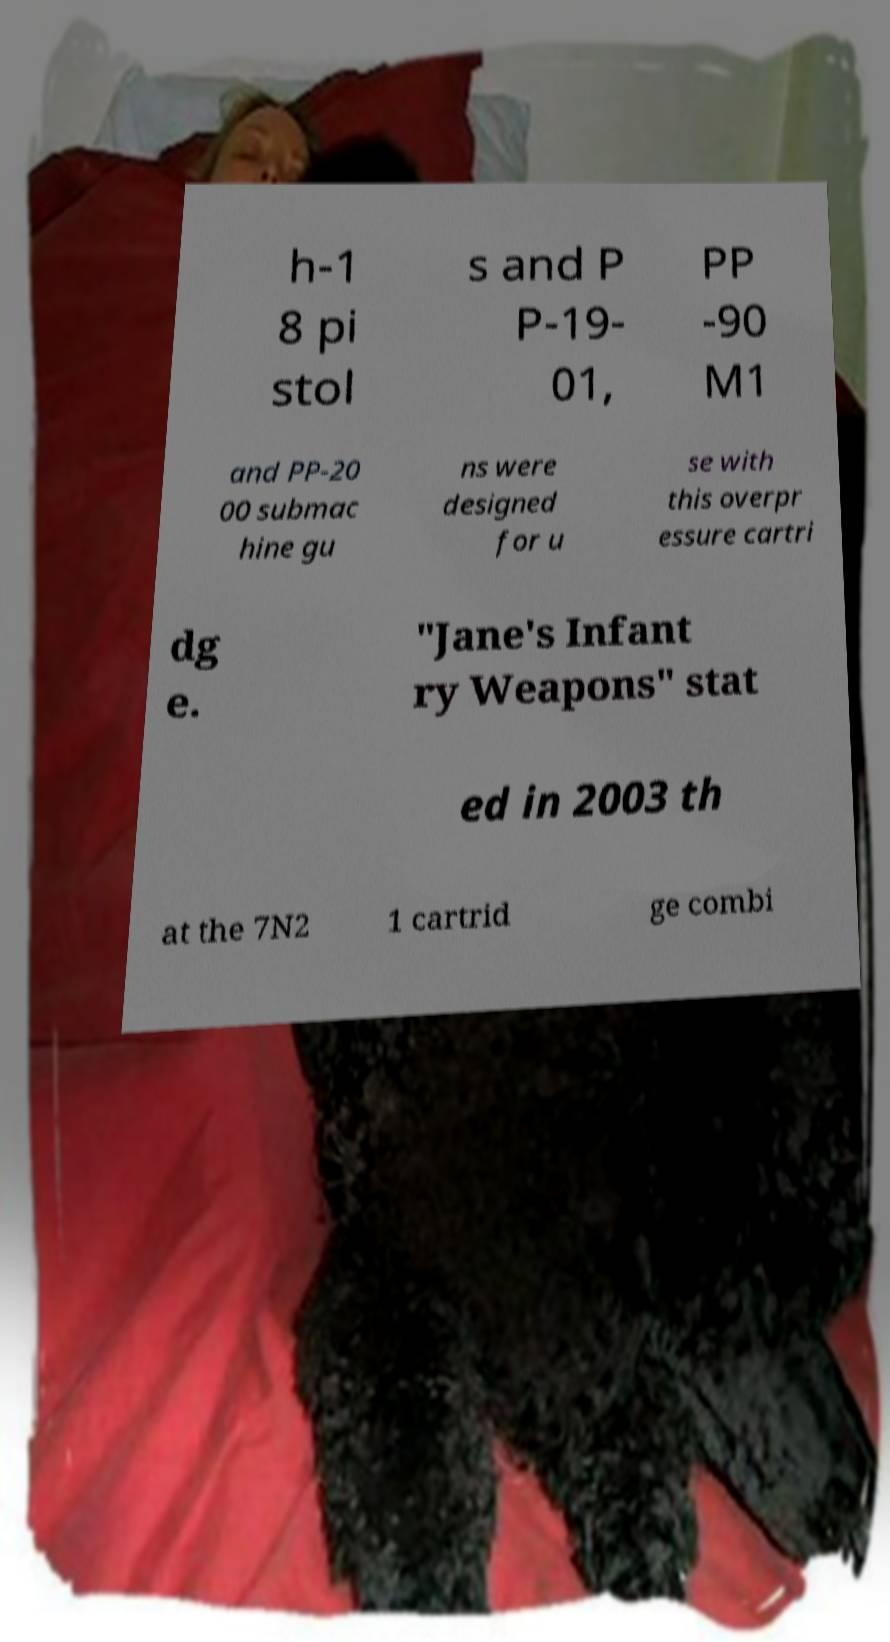Could you assist in decoding the text presented in this image and type it out clearly? h-1 8 pi stol s and P P-19- 01, PP -90 M1 and PP-20 00 submac hine gu ns were designed for u se with this overpr essure cartri dg e. "Jane's Infant ry Weapons" stat ed in 2003 th at the 7N2 1 cartrid ge combi 